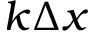Convert formula to latex. <formula><loc_0><loc_0><loc_500><loc_500>k \Delta x</formula> 